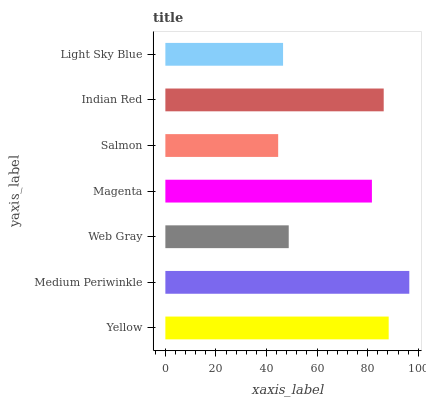Is Salmon the minimum?
Answer yes or no. Yes. Is Medium Periwinkle the maximum?
Answer yes or no. Yes. Is Web Gray the minimum?
Answer yes or no. No. Is Web Gray the maximum?
Answer yes or no. No. Is Medium Periwinkle greater than Web Gray?
Answer yes or no. Yes. Is Web Gray less than Medium Periwinkle?
Answer yes or no. Yes. Is Web Gray greater than Medium Periwinkle?
Answer yes or no. No. Is Medium Periwinkle less than Web Gray?
Answer yes or no. No. Is Magenta the high median?
Answer yes or no. Yes. Is Magenta the low median?
Answer yes or no. Yes. Is Light Sky Blue the high median?
Answer yes or no. No. Is Light Sky Blue the low median?
Answer yes or no. No. 